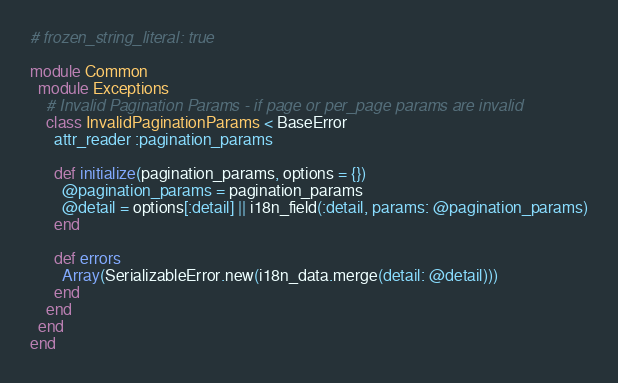Convert code to text. <code><loc_0><loc_0><loc_500><loc_500><_Ruby_># frozen_string_literal: true

module Common
  module Exceptions
    # Invalid Pagination Params - if page or per_page params are invalid
    class InvalidPaginationParams < BaseError
      attr_reader :pagination_params

      def initialize(pagination_params, options = {})
        @pagination_params = pagination_params
        @detail = options[:detail] || i18n_field(:detail, params: @pagination_params)
      end

      def errors
        Array(SerializableError.new(i18n_data.merge(detail: @detail)))
      end
    end
  end
end
</code> 